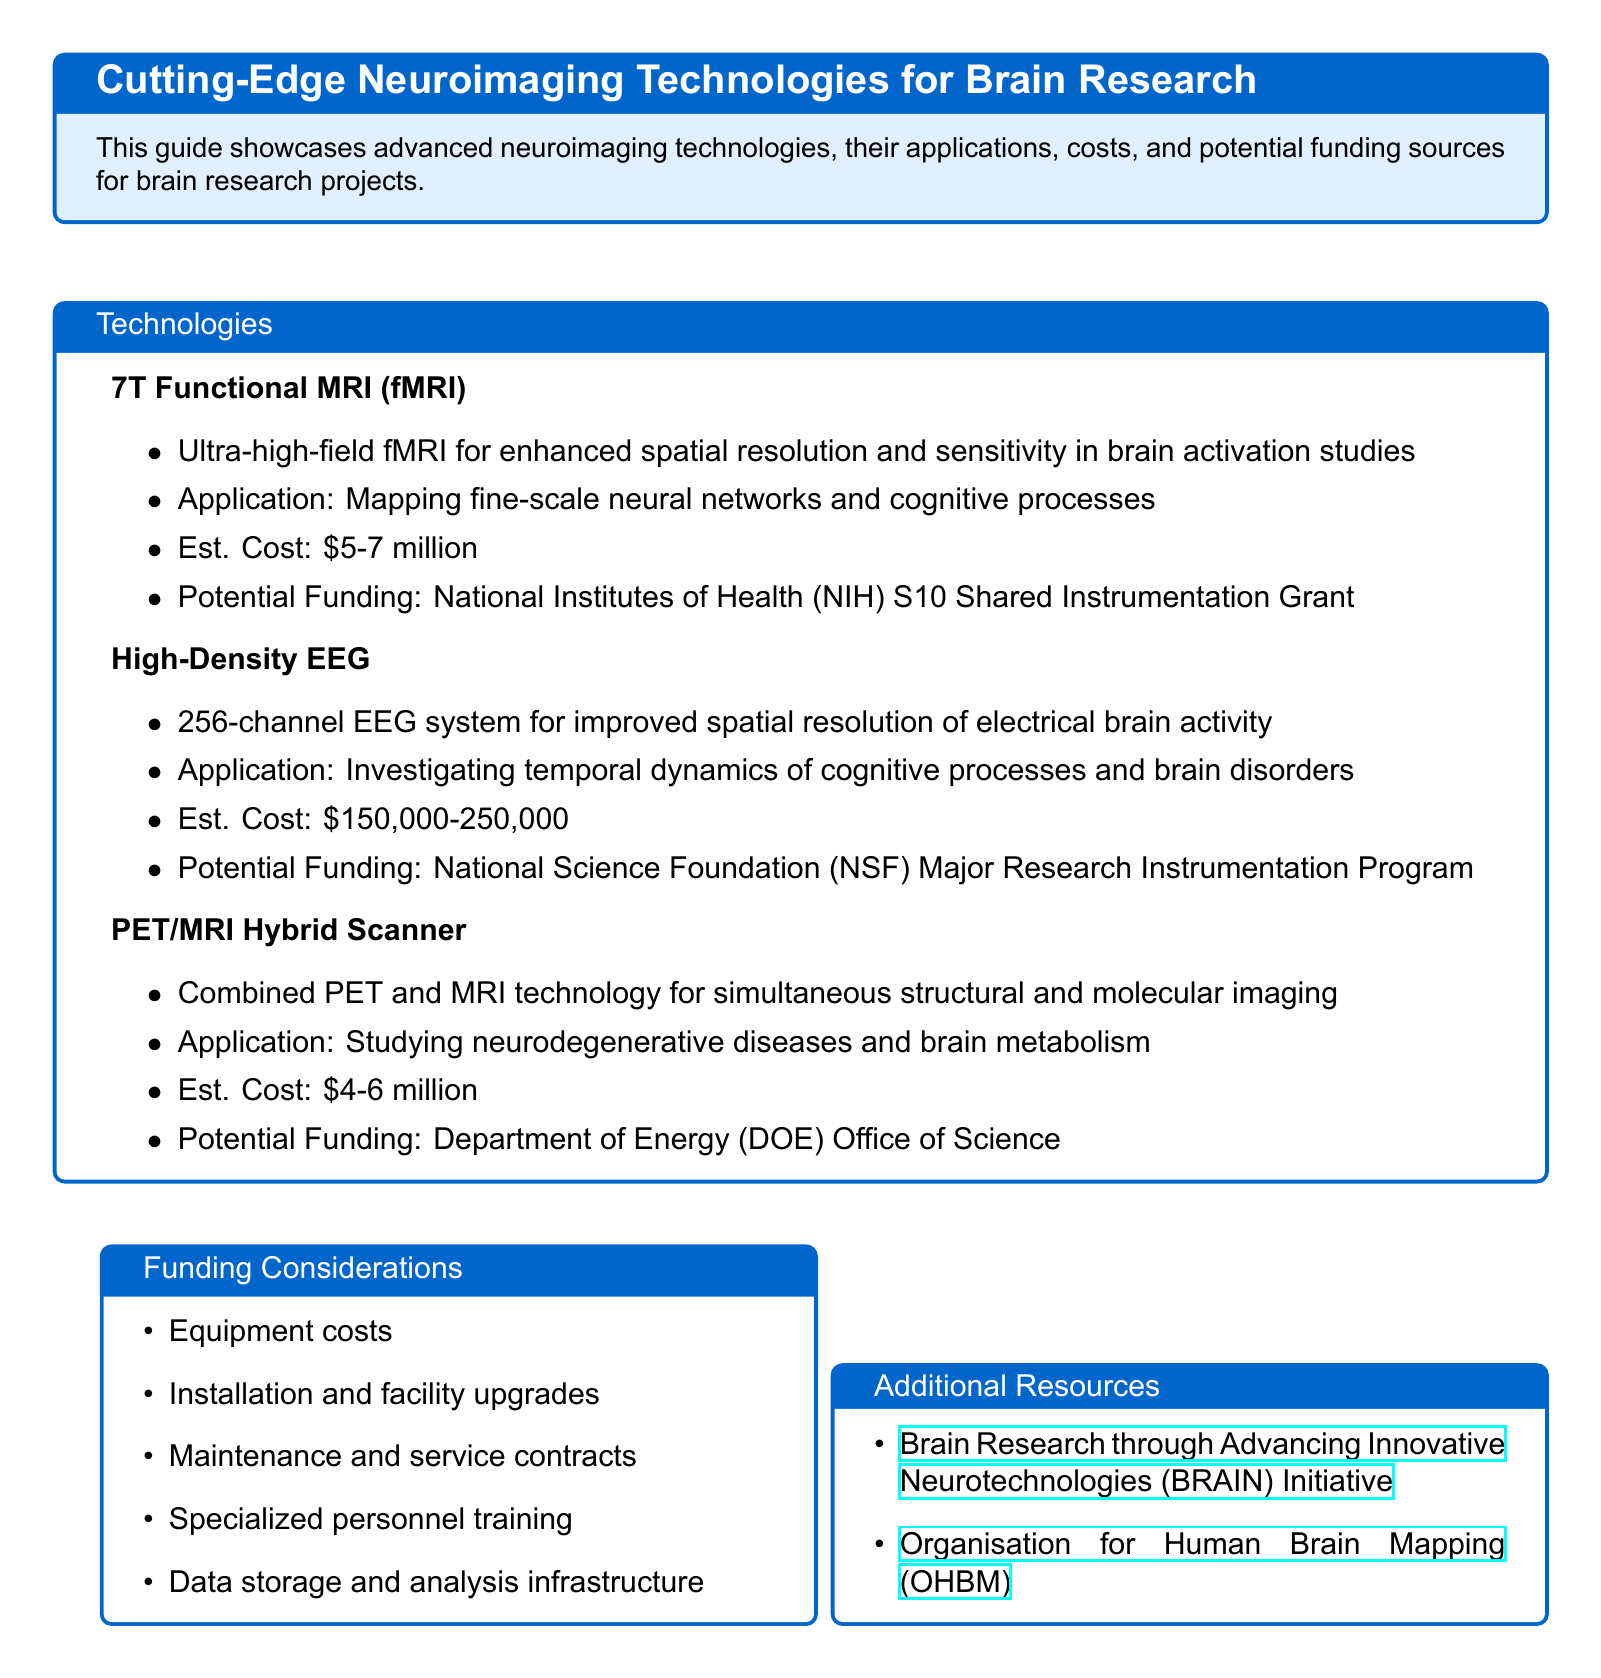What is the cost range for 7T Functional MRI? The cost range is provided in the document under the section for 7T Functional MRI, which states it is \$5-7 million.
Answer: \$5-7 million Which organization offers potential funding for High-Density EEG? The potential funding source for High-Density EEG is mentioned as the National Science Foundation (NSF) Major Research Instrumentation Program.
Answer: National Science Foundation (NSF) Major Research Instrumentation Program What is the main application of the PET/MRI Hybrid Scanner? The application stated in the document for the PET/MRI Hybrid Scanner is studying neurodegenerative diseases and brain metabolism.
Answer: Studying neurodegenerative diseases and brain metabolism What is a key consideration for funding mentioned in the document? The document lists several funding considerations, one of which is maintenance and service contracts as a key consideration.
Answer: Maintenance and service contracts How many channels does the High-Density EEG system have? The document specifies that the High-Density EEG system has 256 channels.
Answer: 256 channels What is the estimated cost for the PET/MRI Hybrid Scanner? The estimated cost range is provided in the section on the PET/MRI Hybrid Scanner, which mentions \$4-6 million.
Answer: \$4-6 million What initiative is linked to brain research? The Brain Research through Advancing Innovative Neurotechnologies (BRAIN) Initiative is mentioned as an initiative linked to brain research in the additional resources section.
Answer: Brain Research through Advancing Innovative Neurotechnologies (BRAIN) Initiative What is one of the applications of 7T Functional MRI? The application listed for 7T Functional MRI is mapping fine-scale neural networks and cognitive processes.
Answer: Mapping fine-scale neural networks and cognitive processes 